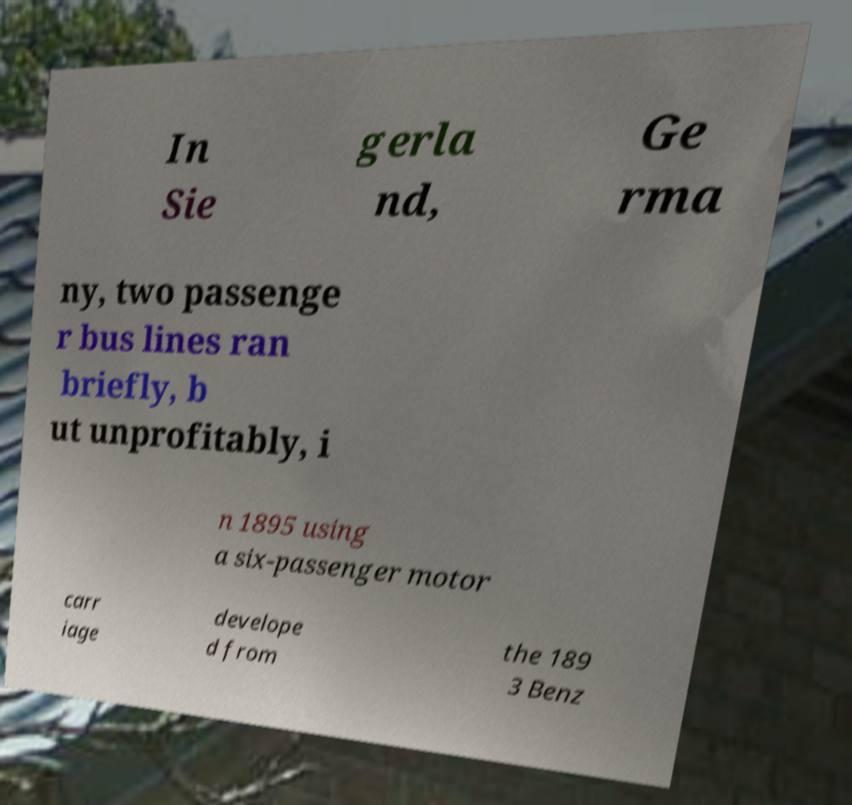Could you assist in decoding the text presented in this image and type it out clearly? In Sie gerla nd, Ge rma ny, two passenge r bus lines ran briefly, b ut unprofitably, i n 1895 using a six-passenger motor carr iage develope d from the 189 3 Benz 